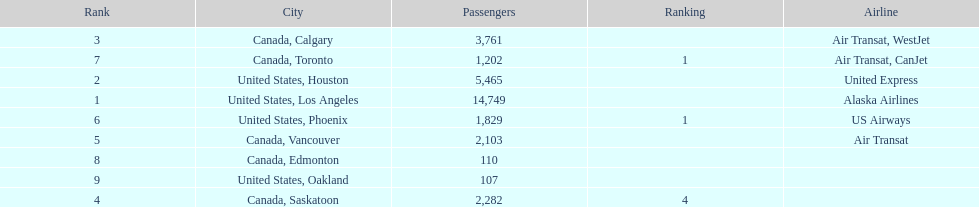Which canadian city had the most passengers traveling from manzanillo international airport in 2013? Calgary. 